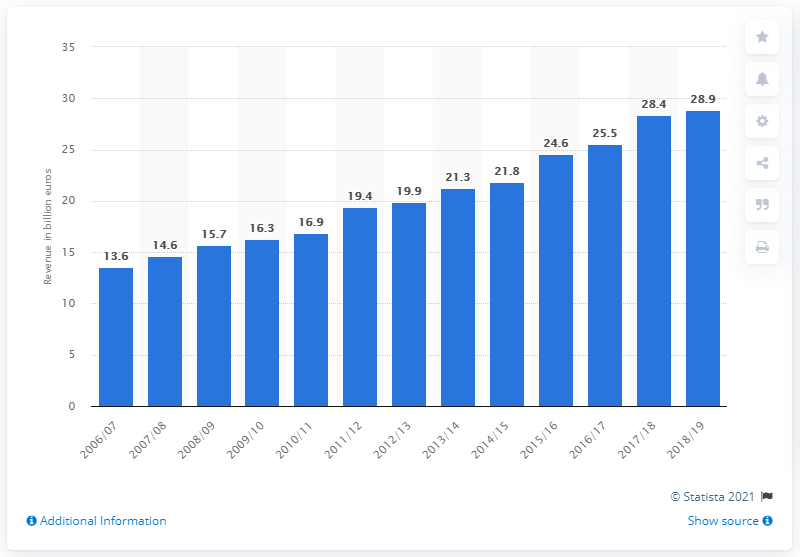Draw attention to some important aspects in this diagram. In the 2018/2019 season, the total revenue of the European professional soccer market was 28.9 billion euros. 